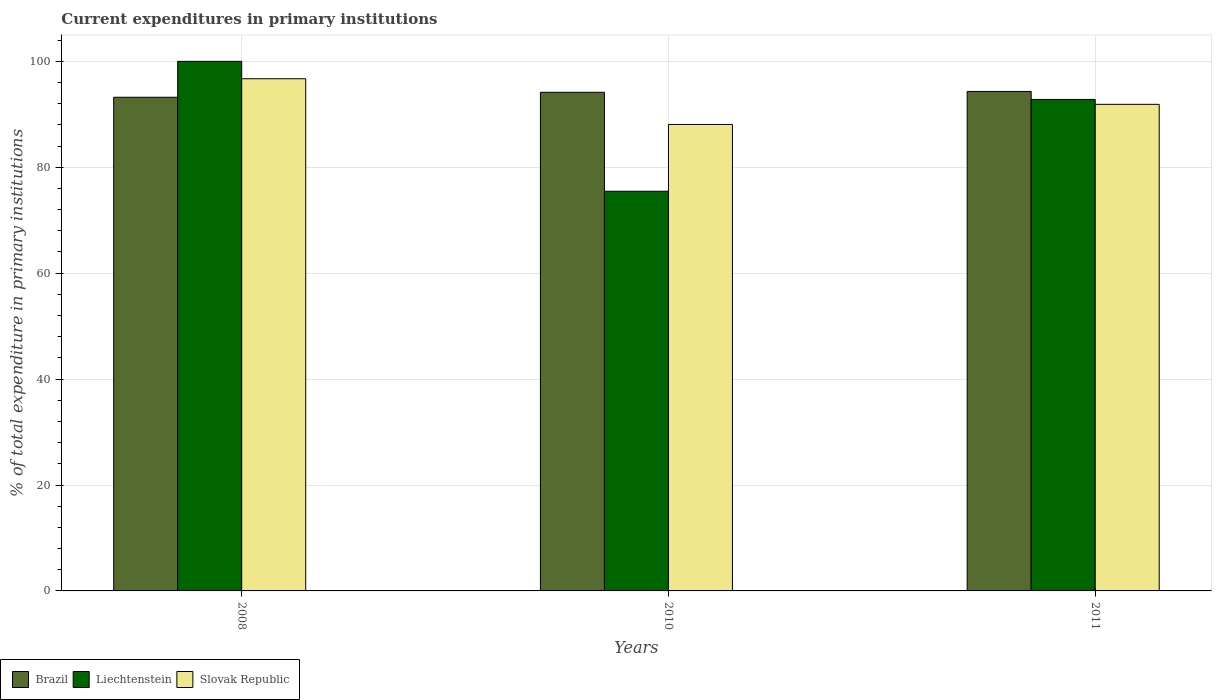How many groups of bars are there?
Make the answer very short. 3. How many bars are there on the 1st tick from the right?
Ensure brevity in your answer.  3. What is the current expenditures in primary institutions in Liechtenstein in 2011?
Give a very brief answer. 92.81. Across all years, what is the maximum current expenditures in primary institutions in Brazil?
Keep it short and to the point. 94.32. Across all years, what is the minimum current expenditures in primary institutions in Brazil?
Keep it short and to the point. 93.22. In which year was the current expenditures in primary institutions in Slovak Republic maximum?
Your answer should be very brief. 2008. In which year was the current expenditures in primary institutions in Liechtenstein minimum?
Make the answer very short. 2010. What is the total current expenditures in primary institutions in Slovak Republic in the graph?
Ensure brevity in your answer.  276.68. What is the difference between the current expenditures in primary institutions in Brazil in 2010 and that in 2011?
Your answer should be compact. -0.16. What is the difference between the current expenditures in primary institutions in Slovak Republic in 2008 and the current expenditures in primary institutions in Liechtenstein in 2011?
Keep it short and to the point. 3.91. What is the average current expenditures in primary institutions in Liechtenstein per year?
Offer a very short reply. 89.43. In the year 2011, what is the difference between the current expenditures in primary institutions in Brazil and current expenditures in primary institutions in Slovak Republic?
Give a very brief answer. 2.43. What is the ratio of the current expenditures in primary institutions in Slovak Republic in 2010 to that in 2011?
Give a very brief answer. 0.96. What is the difference between the highest and the second highest current expenditures in primary institutions in Liechtenstein?
Make the answer very short. 7.19. What is the difference between the highest and the lowest current expenditures in primary institutions in Liechtenstein?
Provide a short and direct response. 24.53. In how many years, is the current expenditures in primary institutions in Liechtenstein greater than the average current expenditures in primary institutions in Liechtenstein taken over all years?
Keep it short and to the point. 2. What does the 2nd bar from the left in 2008 represents?
Offer a very short reply. Liechtenstein. What does the 2nd bar from the right in 2010 represents?
Give a very brief answer. Liechtenstein. Is it the case that in every year, the sum of the current expenditures in primary institutions in Slovak Republic and current expenditures in primary institutions in Liechtenstein is greater than the current expenditures in primary institutions in Brazil?
Offer a very short reply. Yes. How many bars are there?
Keep it short and to the point. 9. How many years are there in the graph?
Offer a very short reply. 3. Are the values on the major ticks of Y-axis written in scientific E-notation?
Ensure brevity in your answer.  No. How are the legend labels stacked?
Keep it short and to the point. Horizontal. What is the title of the graph?
Your answer should be very brief. Current expenditures in primary institutions. What is the label or title of the X-axis?
Give a very brief answer. Years. What is the label or title of the Y-axis?
Provide a short and direct response. % of total expenditure in primary institutions. What is the % of total expenditure in primary institutions of Brazil in 2008?
Keep it short and to the point. 93.22. What is the % of total expenditure in primary institutions of Liechtenstein in 2008?
Your answer should be very brief. 100. What is the % of total expenditure in primary institutions in Slovak Republic in 2008?
Your response must be concise. 96.72. What is the % of total expenditure in primary institutions of Brazil in 2010?
Offer a very short reply. 94.16. What is the % of total expenditure in primary institutions of Liechtenstein in 2010?
Offer a terse response. 75.47. What is the % of total expenditure in primary institutions of Slovak Republic in 2010?
Your answer should be very brief. 88.08. What is the % of total expenditure in primary institutions in Brazil in 2011?
Provide a succinct answer. 94.32. What is the % of total expenditure in primary institutions in Liechtenstein in 2011?
Make the answer very short. 92.81. What is the % of total expenditure in primary institutions of Slovak Republic in 2011?
Keep it short and to the point. 91.88. Across all years, what is the maximum % of total expenditure in primary institutions of Brazil?
Your answer should be compact. 94.32. Across all years, what is the maximum % of total expenditure in primary institutions in Slovak Republic?
Offer a terse response. 96.72. Across all years, what is the minimum % of total expenditure in primary institutions in Brazil?
Provide a short and direct response. 93.22. Across all years, what is the minimum % of total expenditure in primary institutions in Liechtenstein?
Give a very brief answer. 75.47. Across all years, what is the minimum % of total expenditure in primary institutions in Slovak Republic?
Your answer should be very brief. 88.08. What is the total % of total expenditure in primary institutions of Brazil in the graph?
Keep it short and to the point. 281.7. What is the total % of total expenditure in primary institutions in Liechtenstein in the graph?
Provide a short and direct response. 268.28. What is the total % of total expenditure in primary institutions in Slovak Republic in the graph?
Keep it short and to the point. 276.68. What is the difference between the % of total expenditure in primary institutions of Brazil in 2008 and that in 2010?
Offer a very short reply. -0.94. What is the difference between the % of total expenditure in primary institutions in Liechtenstein in 2008 and that in 2010?
Your answer should be very brief. 24.53. What is the difference between the % of total expenditure in primary institutions in Slovak Republic in 2008 and that in 2010?
Make the answer very short. 8.63. What is the difference between the % of total expenditure in primary institutions in Brazil in 2008 and that in 2011?
Keep it short and to the point. -1.1. What is the difference between the % of total expenditure in primary institutions of Liechtenstein in 2008 and that in 2011?
Your answer should be compact. 7.19. What is the difference between the % of total expenditure in primary institutions in Slovak Republic in 2008 and that in 2011?
Make the answer very short. 4.83. What is the difference between the % of total expenditure in primary institutions in Brazil in 2010 and that in 2011?
Provide a succinct answer. -0.16. What is the difference between the % of total expenditure in primary institutions in Liechtenstein in 2010 and that in 2011?
Make the answer very short. -17.34. What is the difference between the % of total expenditure in primary institutions of Slovak Republic in 2010 and that in 2011?
Keep it short and to the point. -3.8. What is the difference between the % of total expenditure in primary institutions in Brazil in 2008 and the % of total expenditure in primary institutions in Liechtenstein in 2010?
Your answer should be very brief. 17.75. What is the difference between the % of total expenditure in primary institutions of Brazil in 2008 and the % of total expenditure in primary institutions of Slovak Republic in 2010?
Ensure brevity in your answer.  5.14. What is the difference between the % of total expenditure in primary institutions in Liechtenstein in 2008 and the % of total expenditure in primary institutions in Slovak Republic in 2010?
Make the answer very short. 11.92. What is the difference between the % of total expenditure in primary institutions in Brazil in 2008 and the % of total expenditure in primary institutions in Liechtenstein in 2011?
Provide a short and direct response. 0.41. What is the difference between the % of total expenditure in primary institutions of Brazil in 2008 and the % of total expenditure in primary institutions of Slovak Republic in 2011?
Ensure brevity in your answer.  1.34. What is the difference between the % of total expenditure in primary institutions of Liechtenstein in 2008 and the % of total expenditure in primary institutions of Slovak Republic in 2011?
Provide a short and direct response. 8.12. What is the difference between the % of total expenditure in primary institutions of Brazil in 2010 and the % of total expenditure in primary institutions of Liechtenstein in 2011?
Offer a terse response. 1.35. What is the difference between the % of total expenditure in primary institutions in Brazil in 2010 and the % of total expenditure in primary institutions in Slovak Republic in 2011?
Ensure brevity in your answer.  2.27. What is the difference between the % of total expenditure in primary institutions of Liechtenstein in 2010 and the % of total expenditure in primary institutions of Slovak Republic in 2011?
Offer a terse response. -16.41. What is the average % of total expenditure in primary institutions of Brazil per year?
Make the answer very short. 93.9. What is the average % of total expenditure in primary institutions of Liechtenstein per year?
Offer a very short reply. 89.43. What is the average % of total expenditure in primary institutions of Slovak Republic per year?
Provide a short and direct response. 92.23. In the year 2008, what is the difference between the % of total expenditure in primary institutions in Brazil and % of total expenditure in primary institutions in Liechtenstein?
Offer a terse response. -6.78. In the year 2008, what is the difference between the % of total expenditure in primary institutions of Brazil and % of total expenditure in primary institutions of Slovak Republic?
Offer a terse response. -3.49. In the year 2008, what is the difference between the % of total expenditure in primary institutions of Liechtenstein and % of total expenditure in primary institutions of Slovak Republic?
Give a very brief answer. 3.28. In the year 2010, what is the difference between the % of total expenditure in primary institutions in Brazil and % of total expenditure in primary institutions in Liechtenstein?
Your answer should be compact. 18.69. In the year 2010, what is the difference between the % of total expenditure in primary institutions of Brazil and % of total expenditure in primary institutions of Slovak Republic?
Give a very brief answer. 6.08. In the year 2010, what is the difference between the % of total expenditure in primary institutions of Liechtenstein and % of total expenditure in primary institutions of Slovak Republic?
Your answer should be compact. -12.61. In the year 2011, what is the difference between the % of total expenditure in primary institutions of Brazil and % of total expenditure in primary institutions of Liechtenstein?
Provide a short and direct response. 1.51. In the year 2011, what is the difference between the % of total expenditure in primary institutions of Brazil and % of total expenditure in primary institutions of Slovak Republic?
Your answer should be very brief. 2.43. In the year 2011, what is the difference between the % of total expenditure in primary institutions in Liechtenstein and % of total expenditure in primary institutions in Slovak Republic?
Give a very brief answer. 0.93. What is the ratio of the % of total expenditure in primary institutions in Liechtenstein in 2008 to that in 2010?
Your answer should be very brief. 1.32. What is the ratio of the % of total expenditure in primary institutions of Slovak Republic in 2008 to that in 2010?
Give a very brief answer. 1.1. What is the ratio of the % of total expenditure in primary institutions of Brazil in 2008 to that in 2011?
Your answer should be compact. 0.99. What is the ratio of the % of total expenditure in primary institutions of Liechtenstein in 2008 to that in 2011?
Provide a short and direct response. 1.08. What is the ratio of the % of total expenditure in primary institutions of Slovak Republic in 2008 to that in 2011?
Your answer should be very brief. 1.05. What is the ratio of the % of total expenditure in primary institutions in Brazil in 2010 to that in 2011?
Make the answer very short. 1. What is the ratio of the % of total expenditure in primary institutions in Liechtenstein in 2010 to that in 2011?
Offer a terse response. 0.81. What is the ratio of the % of total expenditure in primary institutions in Slovak Republic in 2010 to that in 2011?
Make the answer very short. 0.96. What is the difference between the highest and the second highest % of total expenditure in primary institutions of Brazil?
Provide a succinct answer. 0.16. What is the difference between the highest and the second highest % of total expenditure in primary institutions of Liechtenstein?
Offer a terse response. 7.19. What is the difference between the highest and the second highest % of total expenditure in primary institutions of Slovak Republic?
Offer a terse response. 4.83. What is the difference between the highest and the lowest % of total expenditure in primary institutions in Brazil?
Give a very brief answer. 1.1. What is the difference between the highest and the lowest % of total expenditure in primary institutions in Liechtenstein?
Offer a very short reply. 24.53. What is the difference between the highest and the lowest % of total expenditure in primary institutions of Slovak Republic?
Give a very brief answer. 8.63. 